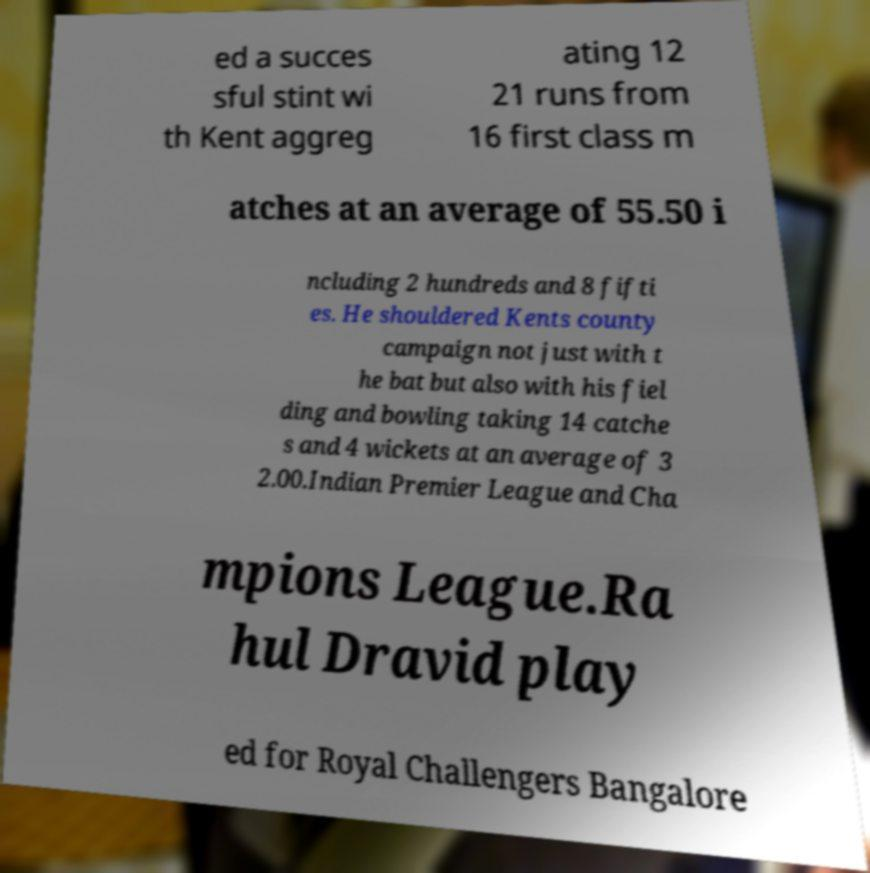Can you read and provide the text displayed in the image?This photo seems to have some interesting text. Can you extract and type it out for me? ed a succes sful stint wi th Kent aggreg ating 12 21 runs from 16 first class m atches at an average of 55.50 i ncluding 2 hundreds and 8 fifti es. He shouldered Kents county campaign not just with t he bat but also with his fiel ding and bowling taking 14 catche s and 4 wickets at an average of 3 2.00.Indian Premier League and Cha mpions League.Ra hul Dravid play ed for Royal Challengers Bangalore 